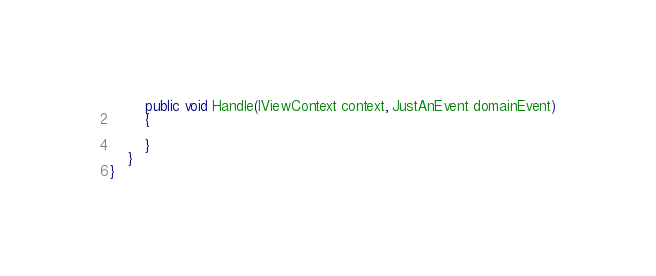Convert code to text. <code><loc_0><loc_0><loc_500><loc_500><_C#_>
        public void Handle(IViewContext context, JustAnEvent domainEvent)
        {

        }
    }
}</code> 